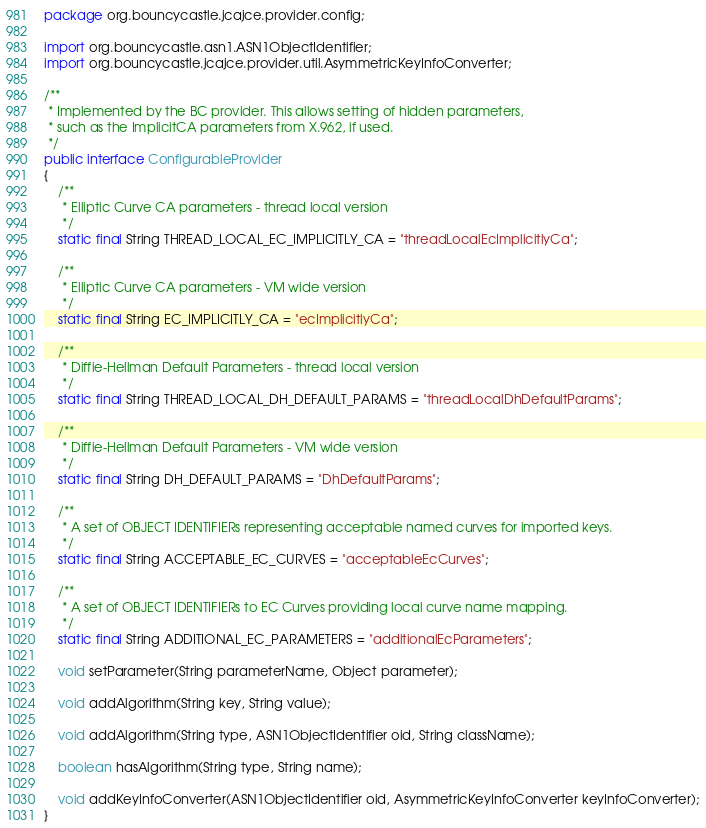Convert code to text. <code><loc_0><loc_0><loc_500><loc_500><_Java_>package org.bouncycastle.jcajce.provider.config;

import org.bouncycastle.asn1.ASN1ObjectIdentifier;
import org.bouncycastle.jcajce.provider.util.AsymmetricKeyInfoConverter;

/**
 * Implemented by the BC provider. This allows setting of hidden parameters,
 * such as the ImplicitCA parameters from X.962, if used.
 */
public interface ConfigurableProvider
{
    /**
     * Elliptic Curve CA parameters - thread local version
     */
    static final String THREAD_LOCAL_EC_IMPLICITLY_CA = "threadLocalEcImplicitlyCa";

    /**
     * Elliptic Curve CA parameters - VM wide version
     */
    static final String EC_IMPLICITLY_CA = "ecImplicitlyCa";

    /**
     * Diffie-Hellman Default Parameters - thread local version
     */
    static final String THREAD_LOCAL_DH_DEFAULT_PARAMS = "threadLocalDhDefaultParams";

    /**
     * Diffie-Hellman Default Parameters - VM wide version
     */
    static final String DH_DEFAULT_PARAMS = "DhDefaultParams";

    /**
     * A set of OBJECT IDENTIFIERs representing acceptable named curves for imported keys.
     */
    static final String ACCEPTABLE_EC_CURVES = "acceptableEcCurves";

    /**
     * A set of OBJECT IDENTIFIERs to EC Curves providing local curve name mapping.
     */
    static final String ADDITIONAL_EC_PARAMETERS = "additionalEcParameters";

    void setParameter(String parameterName, Object parameter);

    void addAlgorithm(String key, String value);

    void addAlgorithm(String type, ASN1ObjectIdentifier oid, String className);

    boolean hasAlgorithm(String type, String name);

    void addKeyInfoConverter(ASN1ObjectIdentifier oid, AsymmetricKeyInfoConverter keyInfoConverter);
}
</code> 